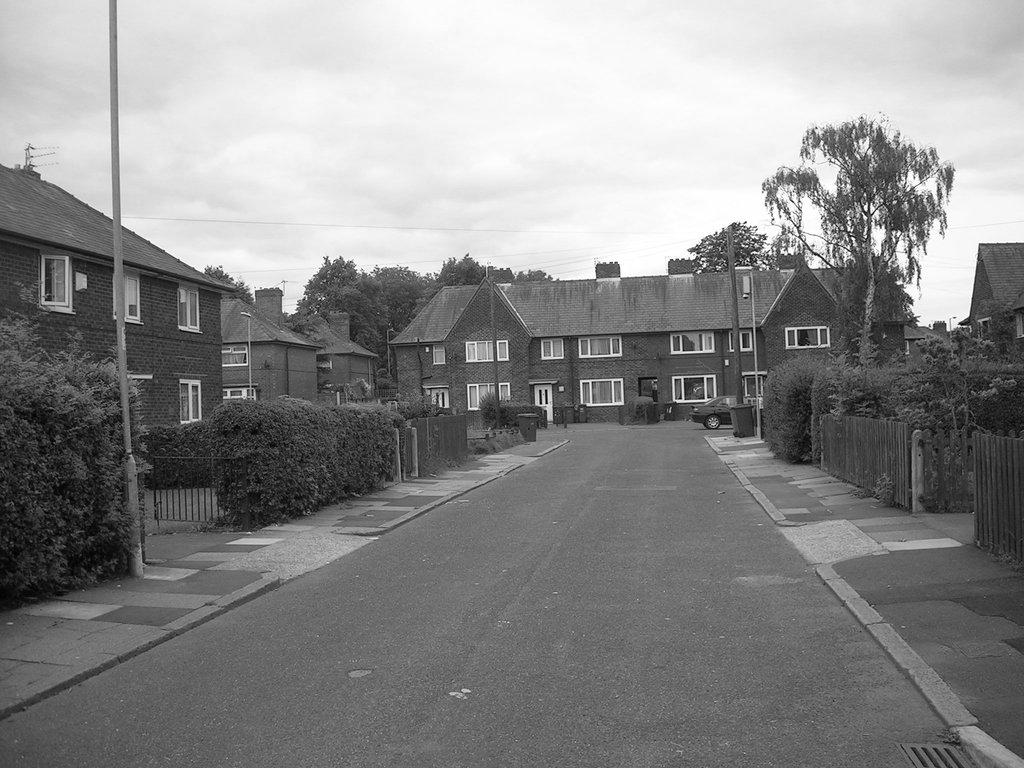What is the color scheme of the image? The image is black and white. What type of structures can be seen in the image? There are houses in the image. What other natural elements are present in the image? There are trees in the image. What man-made objects can be seen in the image? There are poles in the image. What is the main pathway visible in the image? There is a road in the image. What is visible at the top of the image? The sky is visible at the top of the image, and clouds are present in the sky. What type of plant is growing on the channel in the image? There is no channel or plant present in the image. 